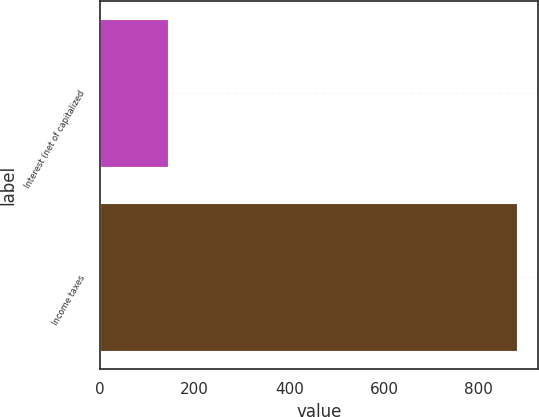<chart> <loc_0><loc_0><loc_500><loc_500><bar_chart><fcel>Interest (net of capitalized<fcel>Income taxes<nl><fcel>145<fcel>880<nl></chart> 